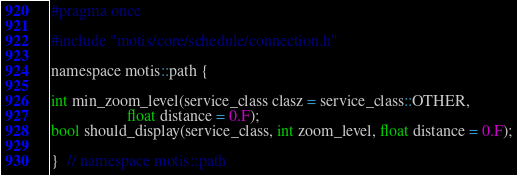<code> <loc_0><loc_0><loc_500><loc_500><_C_>#pragma once

#include "motis/core/schedule/connection.h"

namespace motis::path {

int min_zoom_level(service_class clasz = service_class::OTHER,
                   float distance = 0.F);
bool should_display(service_class, int zoom_level, float distance = 0.F);

}  // namespace motis::path
</code> 